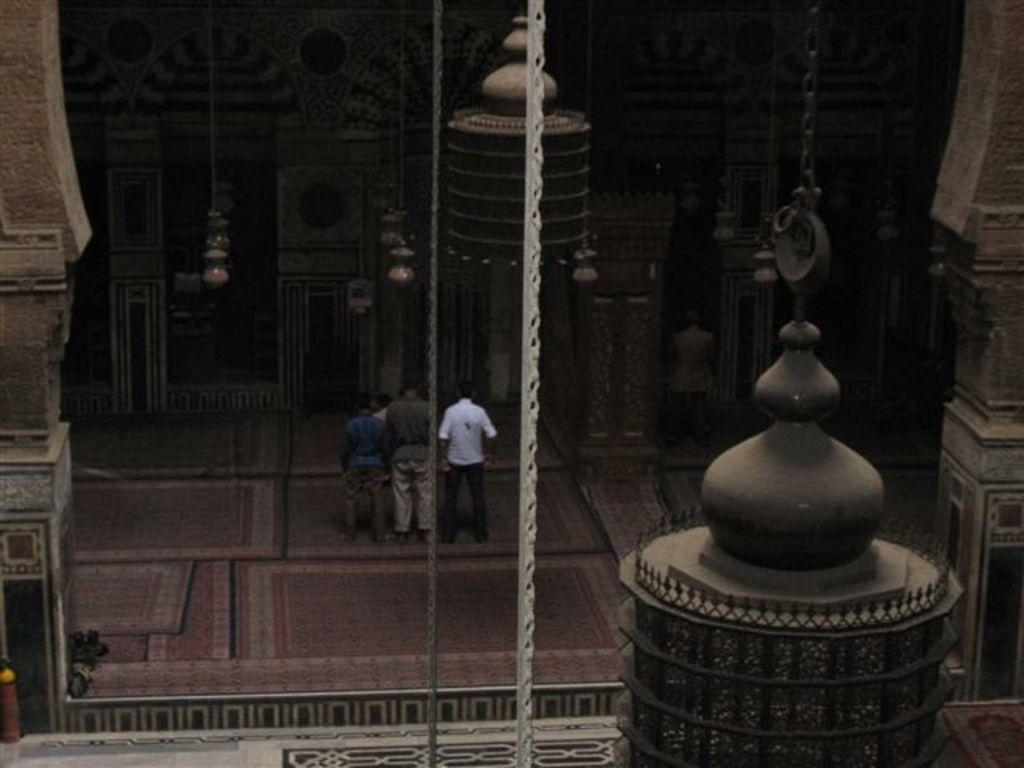What type of building is shown in the image? The image shows an interior view of a cathedral church. Are there any people present in the image? Yes, there are people standing inside the cathedral church. What type of sidewalk can be seen outside the cathedral church in the image? There is no sidewalk visible in the image, as it shows an interior view of the cathedral church. 